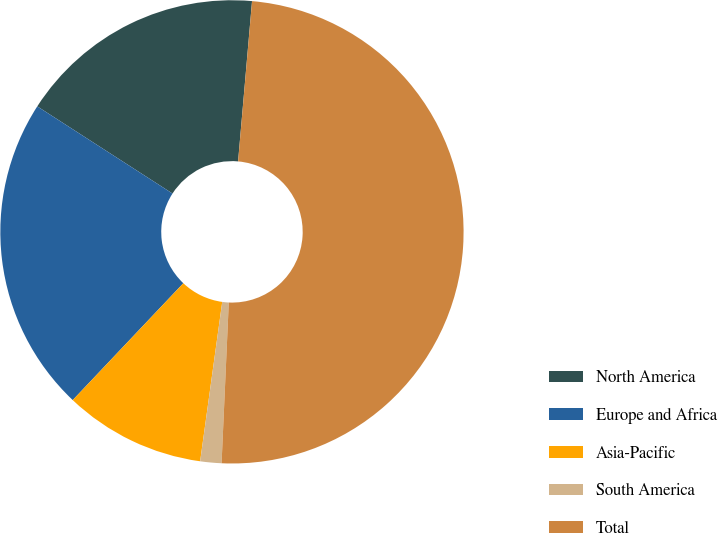Convert chart to OTSL. <chart><loc_0><loc_0><loc_500><loc_500><pie_chart><fcel>North America<fcel>Europe and Africa<fcel>Asia-Pacific<fcel>South America<fcel>Total<nl><fcel>17.27%<fcel>22.05%<fcel>9.87%<fcel>1.48%<fcel>49.33%<nl></chart> 